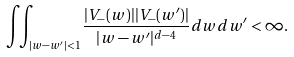Convert formula to latex. <formula><loc_0><loc_0><loc_500><loc_500>\iint _ { | w - w ^ { \prime } | < 1 } \frac { | V _ { - } ( w ) | | V _ { - } ( w ^ { \prime } ) | } { | w - w ^ { \prime } | ^ { d - 4 } } d w d w ^ { \prime } < \infty .</formula> 